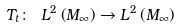<formula> <loc_0><loc_0><loc_500><loc_500>T _ { t } \colon \ L ^ { 2 } \left ( M _ { \infty } \right ) \rightarrow L ^ { 2 } \left ( M _ { \infty } \right )</formula> 